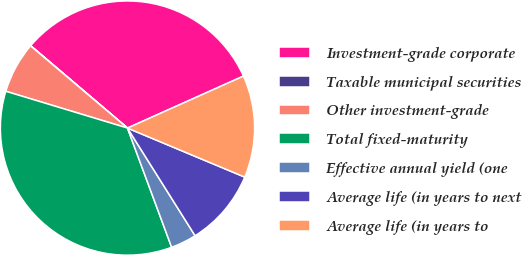Convert chart to OTSL. <chart><loc_0><loc_0><loc_500><loc_500><pie_chart><fcel>Investment-grade corporate<fcel>Taxable municipal securities<fcel>Other investment-grade<fcel>Total fixed-maturity<fcel>Effective annual yield (one<fcel>Average life (in years to next<fcel>Average life (in years to<nl><fcel>32.07%<fcel>0.03%<fcel>6.52%<fcel>35.32%<fcel>3.28%<fcel>9.77%<fcel>13.01%<nl></chart> 